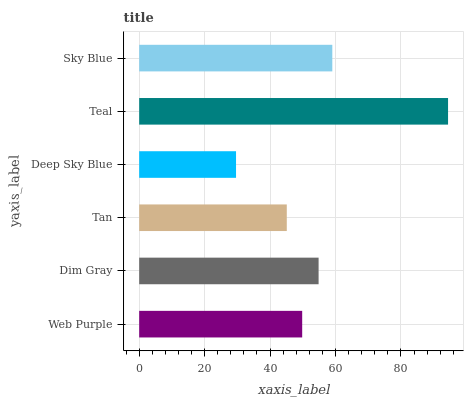Is Deep Sky Blue the minimum?
Answer yes or no. Yes. Is Teal the maximum?
Answer yes or no. Yes. Is Dim Gray the minimum?
Answer yes or no. No. Is Dim Gray the maximum?
Answer yes or no. No. Is Dim Gray greater than Web Purple?
Answer yes or no. Yes. Is Web Purple less than Dim Gray?
Answer yes or no. Yes. Is Web Purple greater than Dim Gray?
Answer yes or no. No. Is Dim Gray less than Web Purple?
Answer yes or no. No. Is Dim Gray the high median?
Answer yes or no. Yes. Is Web Purple the low median?
Answer yes or no. Yes. Is Tan the high median?
Answer yes or no. No. Is Sky Blue the low median?
Answer yes or no. No. 